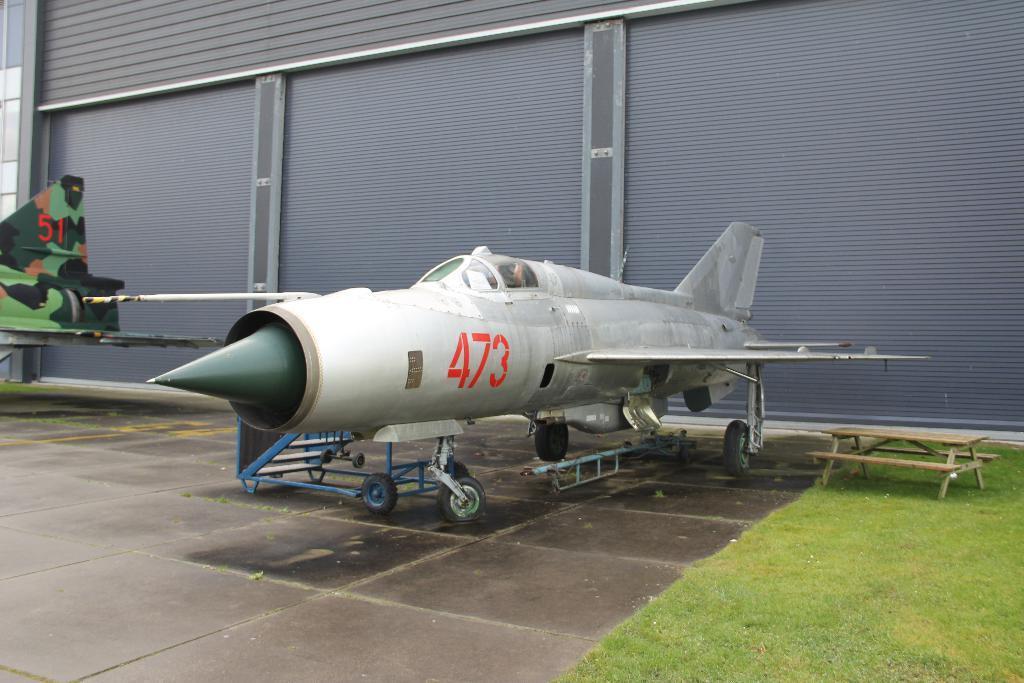Can you describe this image briefly? In the picture there is a plane on the floor ,to the right right there is a grass, in the background there are three shutters of grey color. 